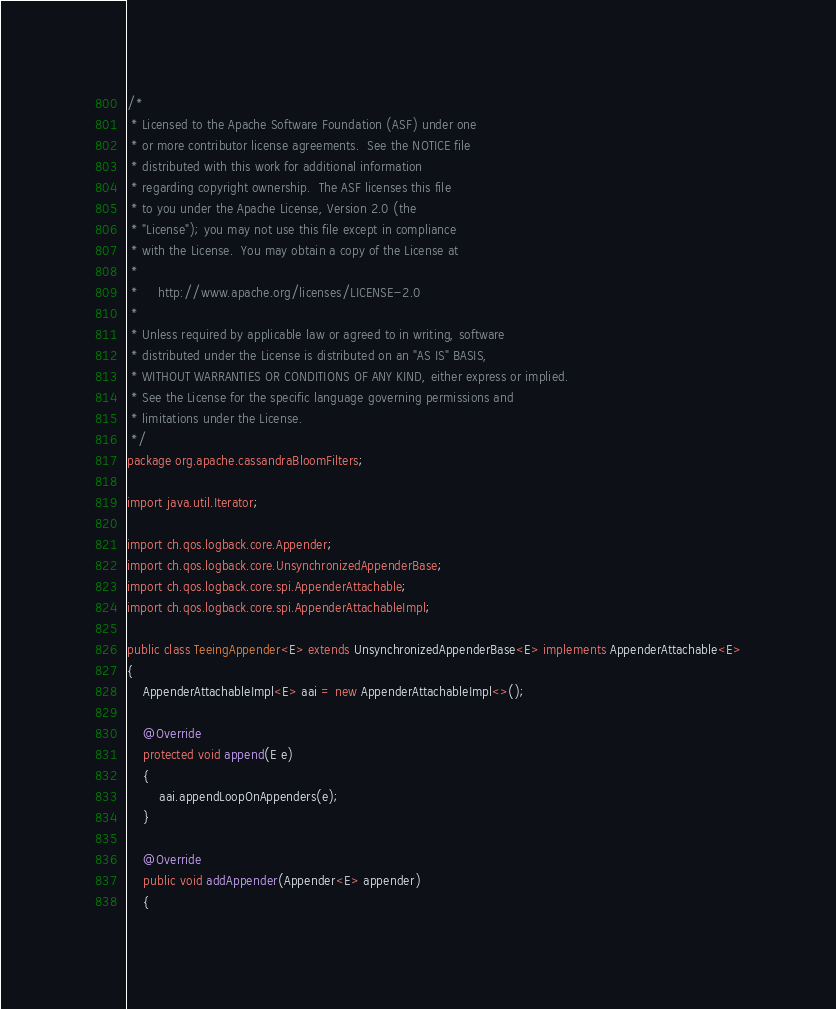Convert code to text. <code><loc_0><loc_0><loc_500><loc_500><_Java_>/*
 * Licensed to the Apache Software Foundation (ASF) under one
 * or more contributor license agreements.  See the NOTICE file
 * distributed with this work for additional information
 * regarding copyright ownership.  The ASF licenses this file
 * to you under the Apache License, Version 2.0 (the
 * "License"); you may not use this file except in compliance
 * with the License.  You may obtain a copy of the License at
 *
 *     http://www.apache.org/licenses/LICENSE-2.0
 *
 * Unless required by applicable law or agreed to in writing, software
 * distributed under the License is distributed on an "AS IS" BASIS,
 * WITHOUT WARRANTIES OR CONDITIONS OF ANY KIND, either express or implied.
 * See the License for the specific language governing permissions and
 * limitations under the License.
 */
package org.apache.cassandraBloomFilters;

import java.util.Iterator;

import ch.qos.logback.core.Appender;
import ch.qos.logback.core.UnsynchronizedAppenderBase;
import ch.qos.logback.core.spi.AppenderAttachable;
import ch.qos.logback.core.spi.AppenderAttachableImpl;

public class TeeingAppender<E> extends UnsynchronizedAppenderBase<E> implements AppenderAttachable<E>
{
    AppenderAttachableImpl<E> aai = new AppenderAttachableImpl<>();

    @Override
    protected void append(E e)
    {
        aai.appendLoopOnAppenders(e);
    }

    @Override
    public void addAppender(Appender<E> appender)
    {</code> 